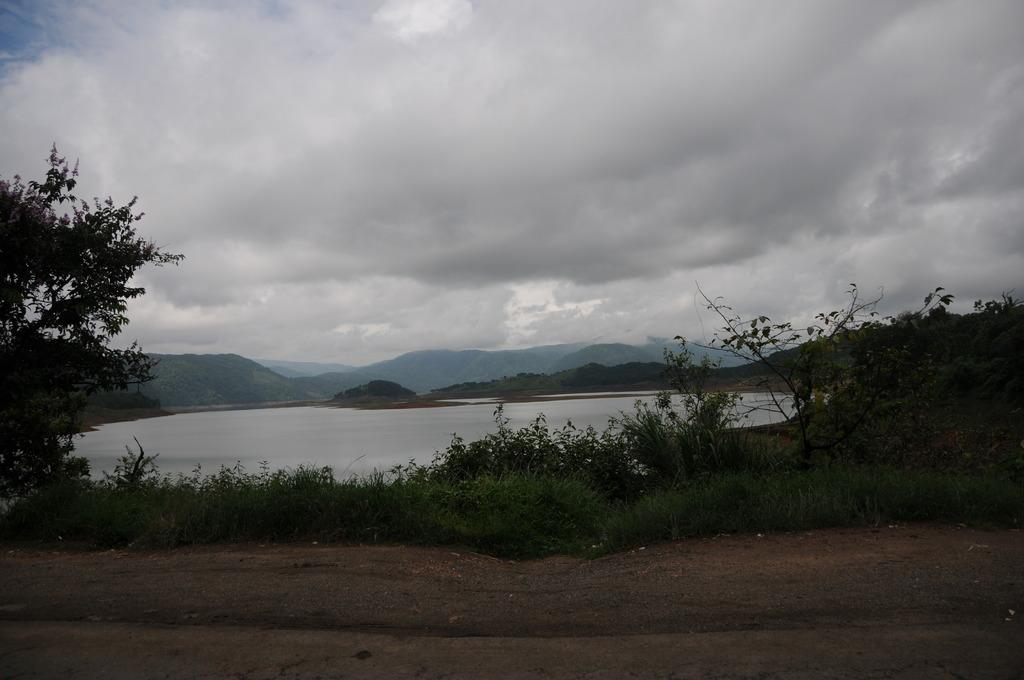What type of landscape is depicted in the image? The image features hills, trees, and grass, indicating a natural landscape. What type of vegetation can be seen in the image? Trees and grass are visible in the image. What is the condition of the sky in the image? The sky is cloudy at the top of the image. What type of man-made structure is present in the image? There is a road at the bottom of the image. Can you see a prison in the image? No, there is no prison present in the image. Is there a goose walking on the grass in the image? No, there is no goose present in the image. 